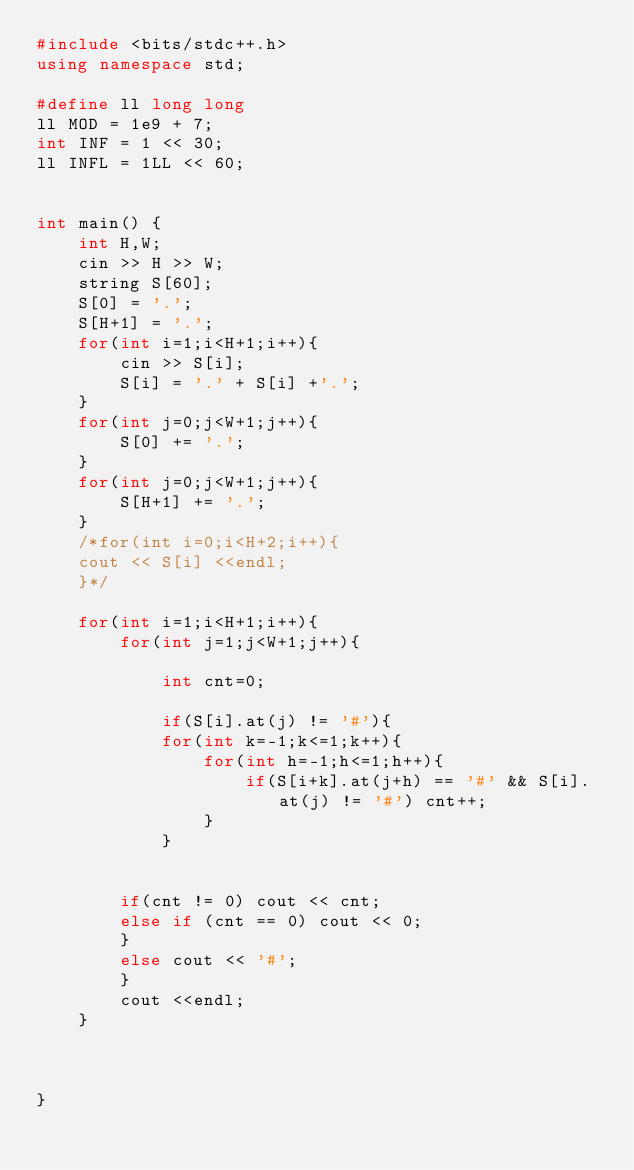Convert code to text. <code><loc_0><loc_0><loc_500><loc_500><_C++_>#include <bits/stdc++.h>
using namespace std;

#define ll long long
ll MOD = 1e9 + 7;
int INF = 1 << 30;
ll INFL = 1LL << 60;


int main() {
    int H,W;
    cin >> H >> W;
    string S[60];
    S[0] = '.';
    S[H+1] = '.';
    for(int i=1;i<H+1;i++){
        cin >> S[i];
        S[i] = '.' + S[i] +'.';
    }
    for(int j=0;j<W+1;j++){
        S[0] += '.';
    }
    for(int j=0;j<W+1;j++){
        S[H+1] += '.';
    }
    /*for(int i=0;i<H+2;i++){
    cout << S[i] <<endl;
    }*/
    
    for(int i=1;i<H+1;i++){
        for(int j=1;j<W+1;j++){
            
            int cnt=0;
            
            if(S[i].at(j) != '#'){
            for(int k=-1;k<=1;k++){
                for(int h=-1;h<=1;h++){
                    if(S[i+k].at(j+h) == '#' && S[i].at(j) != '#') cnt++;
                }
            }
            
            
        if(cnt != 0) cout << cnt;
        else if (cnt == 0) cout << 0;
        }
        else cout << '#';
        }
        cout <<endl;
    }
    
    
    
}</code> 